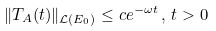Convert formula to latex. <formula><loc_0><loc_0><loc_500><loc_500>\| T _ { A } ( t ) \| _ { \mathcal { L } ( E _ { 0 } ) } \leq c e ^ { - \omega t } \, , \, t > 0</formula> 